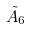Convert formula to latex. <formula><loc_0><loc_0><loc_500><loc_500>\tilde { A } _ { 6 }</formula> 